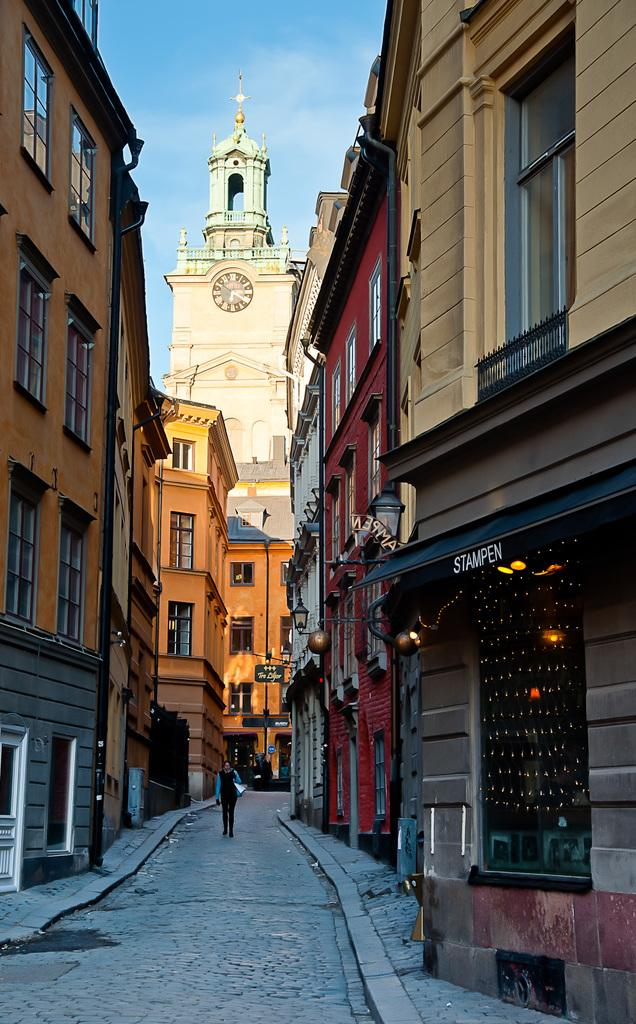What is the main subject of the image? There is a person on the road in the image. What else can be seen in the image besides the person? There are buildings, boards, lights, and a clock in the image. What is the background of the image? The sky is visible in the background of the image. What type of health issues can be seen affecting the person in the image? There is no indication of any health issues affecting the person in the image. What type of office furniture can be seen in the image? There is no office furniture present in the image. 